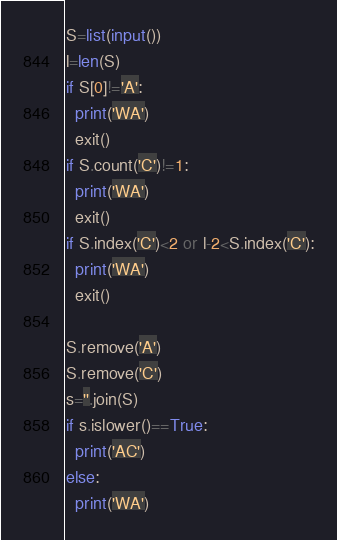<code> <loc_0><loc_0><loc_500><loc_500><_Python_>S=list(input())
l=len(S)
if S[0]!='A':
  print('WA')
  exit()
if S.count('C')!=1:
  print('WA')
  exit()
if S.index('C')<2 or l-2<S.index('C'):
  print('WA')
  exit()
  
S.remove('A')
S.remove('C')
s=''.join(S)
if s.islower()==True:
  print('AC')
else:
  print('WA')</code> 